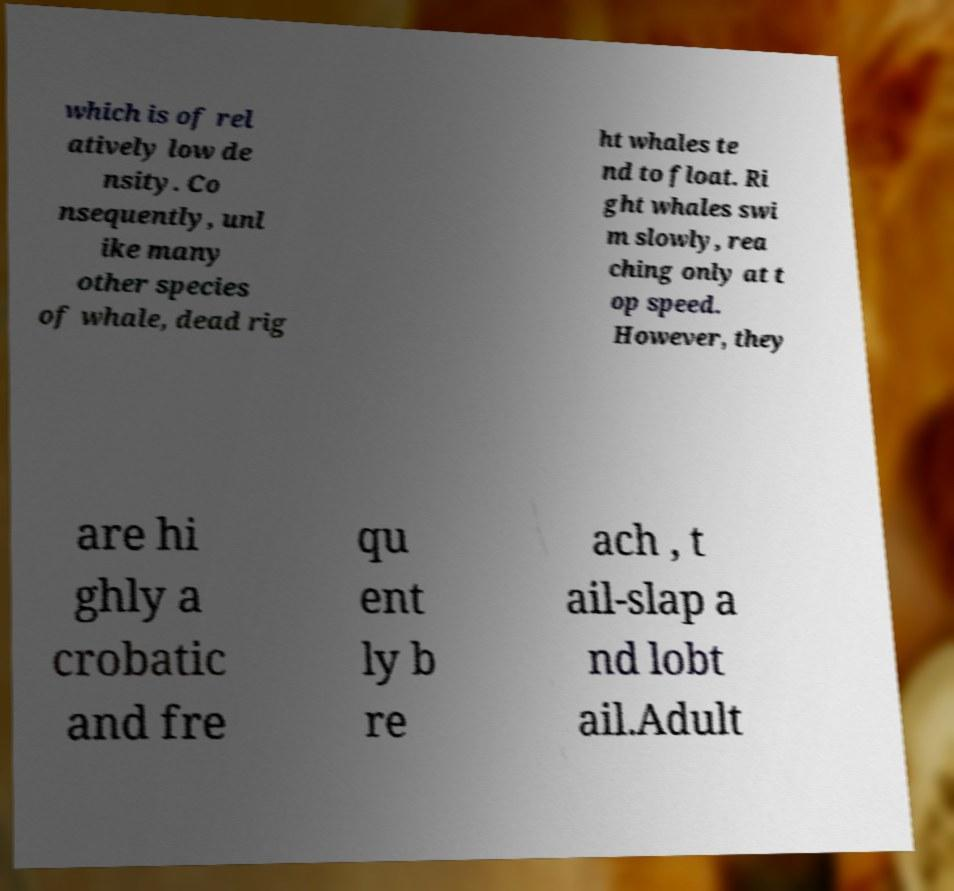Can you accurately transcribe the text from the provided image for me? which is of rel atively low de nsity. Co nsequently, unl ike many other species of whale, dead rig ht whales te nd to float. Ri ght whales swi m slowly, rea ching only at t op speed. However, they are hi ghly a crobatic and fre qu ent ly b re ach , t ail-slap a nd lobt ail.Adult 